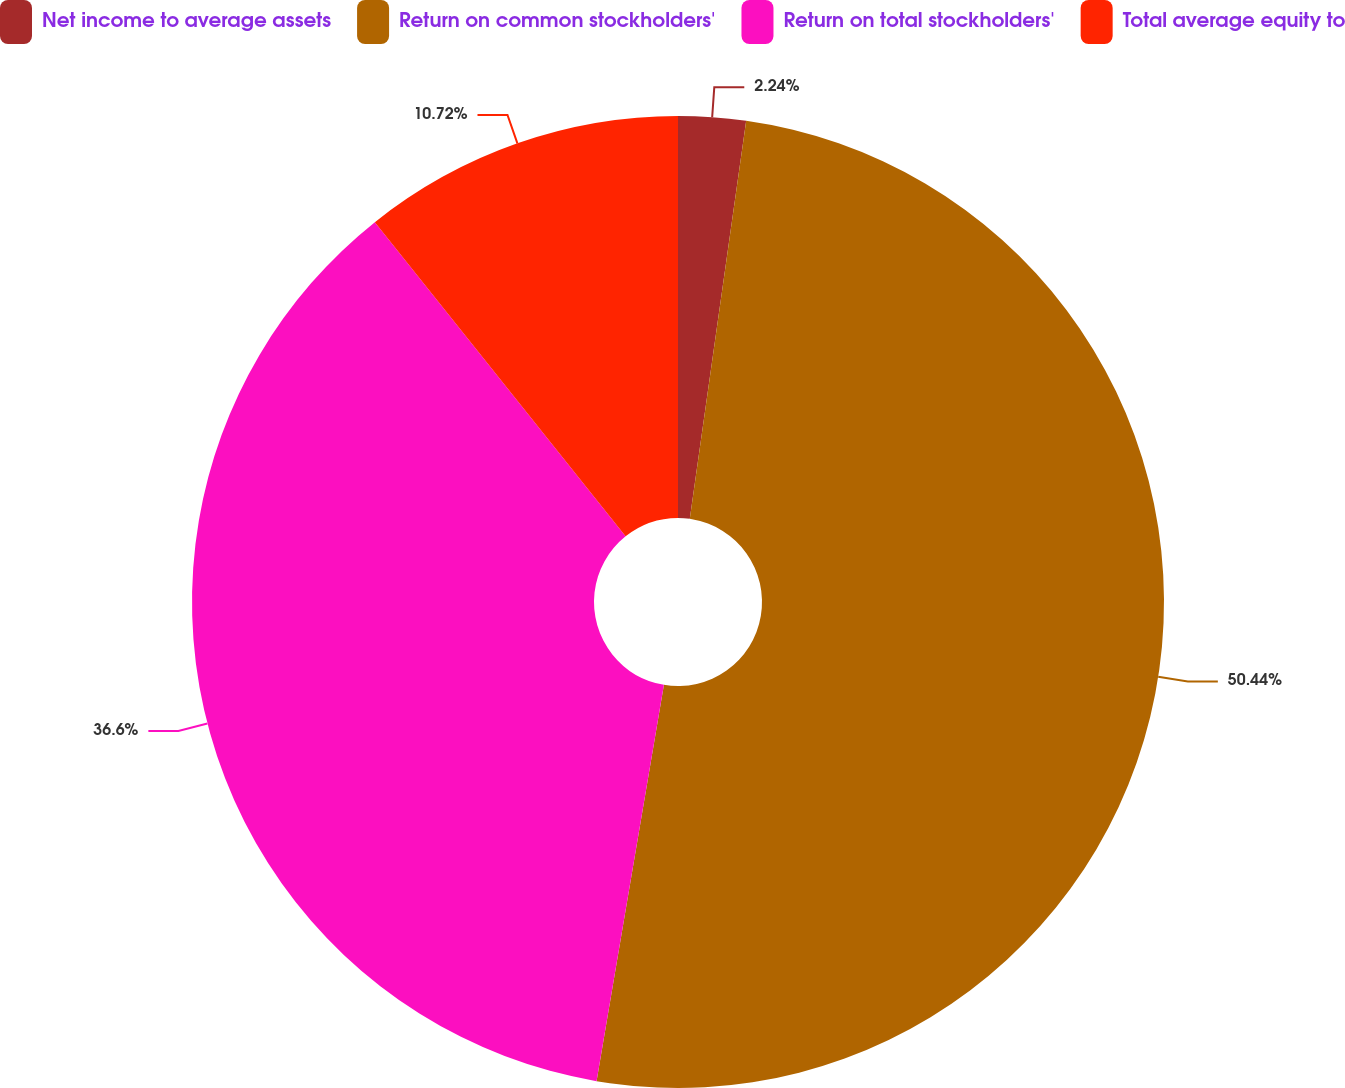Convert chart. <chart><loc_0><loc_0><loc_500><loc_500><pie_chart><fcel>Net income to average assets<fcel>Return on common stockholders'<fcel>Return on total stockholders'<fcel>Total average equity to<nl><fcel>2.24%<fcel>50.44%<fcel>36.6%<fcel>10.72%<nl></chart> 